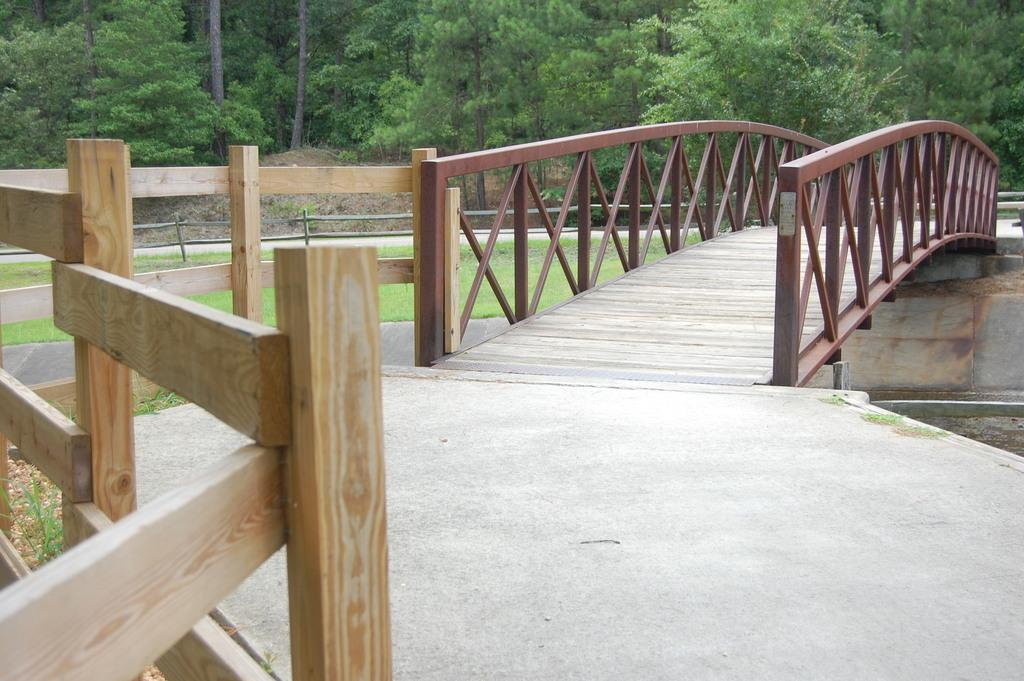What structure can be seen in the image? There is a bridge in the image. What is visible beneath the bridge? The ground is visible in the image. What type of vegetation is present on the ground? There is grass on the ground. What type of barrier is present in the image? There is a fence in the image. What type of natural scenery can be seen in the image? There are trees in the image. What color is the suit worn by the tree in the image? There is no suit or tree wearing a suit present in the image. 